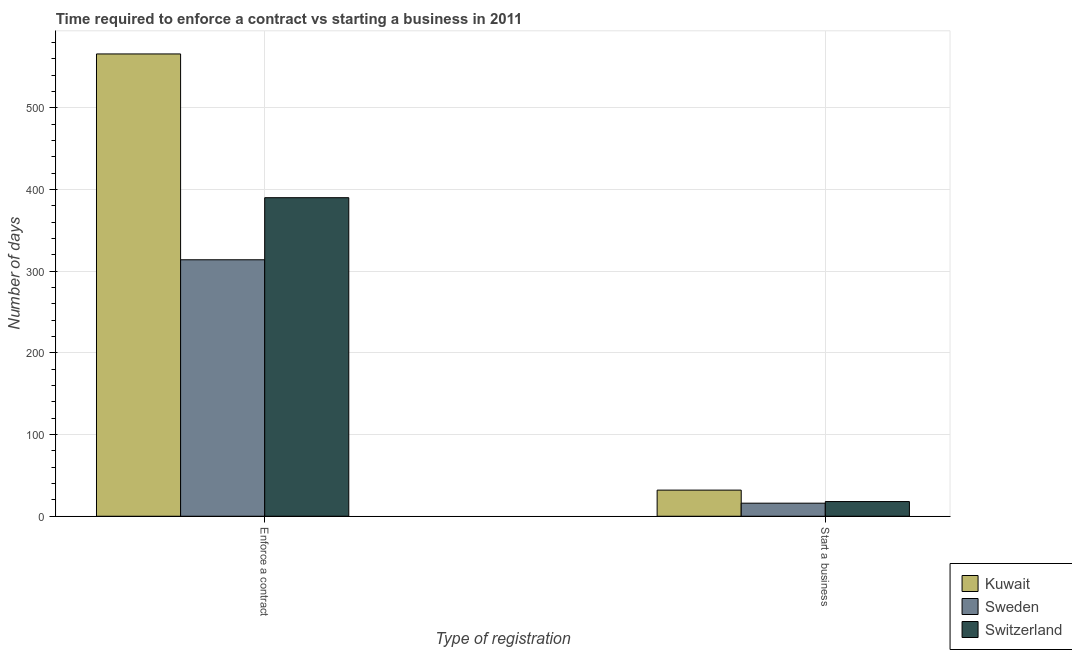How many different coloured bars are there?
Offer a terse response. 3. How many groups of bars are there?
Provide a short and direct response. 2. How many bars are there on the 2nd tick from the left?
Offer a very short reply. 3. What is the label of the 1st group of bars from the left?
Provide a succinct answer. Enforce a contract. What is the number of days to start a business in Switzerland?
Offer a very short reply. 18. Across all countries, what is the maximum number of days to enforece a contract?
Give a very brief answer. 566. Across all countries, what is the minimum number of days to start a business?
Offer a very short reply. 16. In which country was the number of days to enforece a contract maximum?
Offer a terse response. Kuwait. In which country was the number of days to start a business minimum?
Your answer should be compact. Sweden. What is the total number of days to enforece a contract in the graph?
Keep it short and to the point. 1270. What is the difference between the number of days to enforece a contract in Switzerland and that in Sweden?
Your answer should be compact. 76. What is the difference between the number of days to enforece a contract in Kuwait and the number of days to start a business in Switzerland?
Your answer should be compact. 548. What is the average number of days to enforece a contract per country?
Your answer should be very brief. 423.33. What is the difference between the number of days to start a business and number of days to enforece a contract in Kuwait?
Give a very brief answer. -534. What is the ratio of the number of days to start a business in Switzerland to that in Kuwait?
Provide a succinct answer. 0.56. Is the number of days to enforece a contract in Sweden less than that in Kuwait?
Your response must be concise. Yes. What does the 2nd bar from the left in Start a business represents?
Provide a succinct answer. Sweden. What does the 1st bar from the right in Enforce a contract represents?
Make the answer very short. Switzerland. How many bars are there?
Keep it short and to the point. 6. Are all the bars in the graph horizontal?
Keep it short and to the point. No. How many countries are there in the graph?
Provide a short and direct response. 3. Are the values on the major ticks of Y-axis written in scientific E-notation?
Your answer should be very brief. No. Does the graph contain grids?
Offer a terse response. Yes. How many legend labels are there?
Your response must be concise. 3. What is the title of the graph?
Your response must be concise. Time required to enforce a contract vs starting a business in 2011. What is the label or title of the X-axis?
Give a very brief answer. Type of registration. What is the label or title of the Y-axis?
Give a very brief answer. Number of days. What is the Number of days in Kuwait in Enforce a contract?
Make the answer very short. 566. What is the Number of days in Sweden in Enforce a contract?
Offer a very short reply. 314. What is the Number of days of Switzerland in Enforce a contract?
Make the answer very short. 390. What is the Number of days of Switzerland in Start a business?
Your response must be concise. 18. Across all Type of registration, what is the maximum Number of days of Kuwait?
Provide a succinct answer. 566. Across all Type of registration, what is the maximum Number of days in Sweden?
Your answer should be very brief. 314. Across all Type of registration, what is the maximum Number of days in Switzerland?
Offer a terse response. 390. Across all Type of registration, what is the minimum Number of days of Switzerland?
Make the answer very short. 18. What is the total Number of days in Kuwait in the graph?
Offer a very short reply. 598. What is the total Number of days of Sweden in the graph?
Keep it short and to the point. 330. What is the total Number of days in Switzerland in the graph?
Your response must be concise. 408. What is the difference between the Number of days of Kuwait in Enforce a contract and that in Start a business?
Offer a very short reply. 534. What is the difference between the Number of days of Sweden in Enforce a contract and that in Start a business?
Keep it short and to the point. 298. What is the difference between the Number of days in Switzerland in Enforce a contract and that in Start a business?
Make the answer very short. 372. What is the difference between the Number of days of Kuwait in Enforce a contract and the Number of days of Sweden in Start a business?
Make the answer very short. 550. What is the difference between the Number of days in Kuwait in Enforce a contract and the Number of days in Switzerland in Start a business?
Ensure brevity in your answer.  548. What is the difference between the Number of days in Sweden in Enforce a contract and the Number of days in Switzerland in Start a business?
Make the answer very short. 296. What is the average Number of days of Kuwait per Type of registration?
Provide a short and direct response. 299. What is the average Number of days in Sweden per Type of registration?
Your answer should be compact. 165. What is the average Number of days of Switzerland per Type of registration?
Make the answer very short. 204. What is the difference between the Number of days of Kuwait and Number of days of Sweden in Enforce a contract?
Offer a very short reply. 252. What is the difference between the Number of days of Kuwait and Number of days of Switzerland in Enforce a contract?
Your response must be concise. 176. What is the difference between the Number of days of Sweden and Number of days of Switzerland in Enforce a contract?
Offer a terse response. -76. What is the difference between the Number of days in Kuwait and Number of days in Switzerland in Start a business?
Provide a short and direct response. 14. What is the difference between the Number of days in Sweden and Number of days in Switzerland in Start a business?
Your answer should be compact. -2. What is the ratio of the Number of days in Kuwait in Enforce a contract to that in Start a business?
Your answer should be compact. 17.69. What is the ratio of the Number of days of Sweden in Enforce a contract to that in Start a business?
Your answer should be very brief. 19.62. What is the ratio of the Number of days in Switzerland in Enforce a contract to that in Start a business?
Your answer should be compact. 21.67. What is the difference between the highest and the second highest Number of days in Kuwait?
Provide a short and direct response. 534. What is the difference between the highest and the second highest Number of days of Sweden?
Your response must be concise. 298. What is the difference between the highest and the second highest Number of days in Switzerland?
Provide a succinct answer. 372. What is the difference between the highest and the lowest Number of days of Kuwait?
Make the answer very short. 534. What is the difference between the highest and the lowest Number of days of Sweden?
Offer a terse response. 298. What is the difference between the highest and the lowest Number of days of Switzerland?
Provide a succinct answer. 372. 